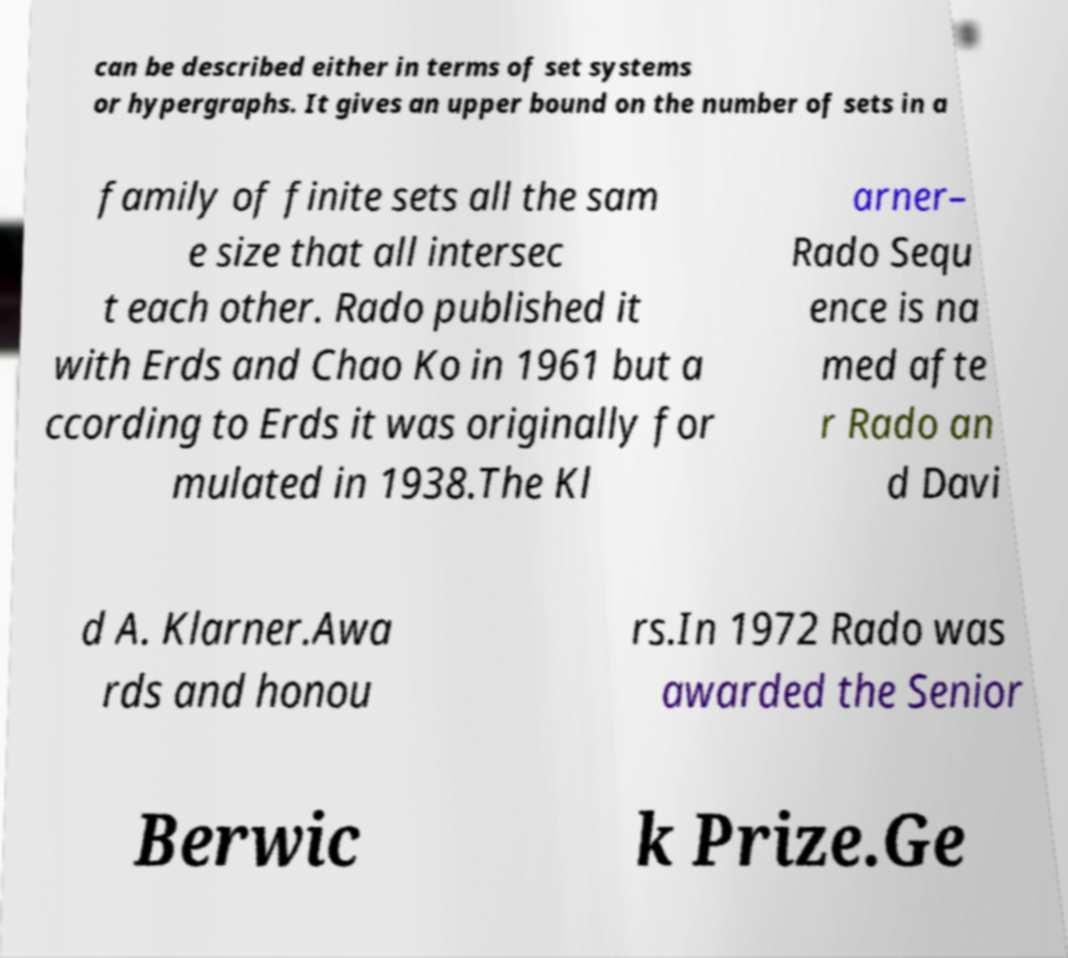Could you extract and type out the text from this image? can be described either in terms of set systems or hypergraphs. It gives an upper bound on the number of sets in a family of finite sets all the sam e size that all intersec t each other. Rado published it with Erds and Chao Ko in 1961 but a ccording to Erds it was originally for mulated in 1938.The Kl arner– Rado Sequ ence is na med afte r Rado an d Davi d A. Klarner.Awa rds and honou rs.In 1972 Rado was awarded the Senior Berwic k Prize.Ge 